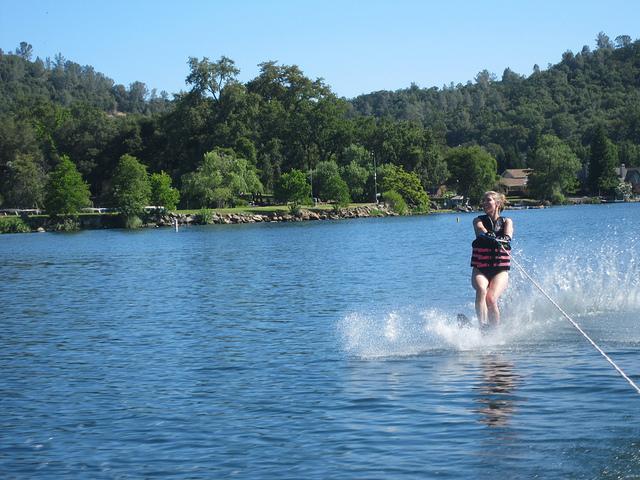What color is the woman wearing?
Keep it brief. Black. What is the background landscape made up of?
Answer briefly. Trees. What is the woman doing?
Quick response, please. Water skiing. Is the water placid?
Short answer required. Yes. 